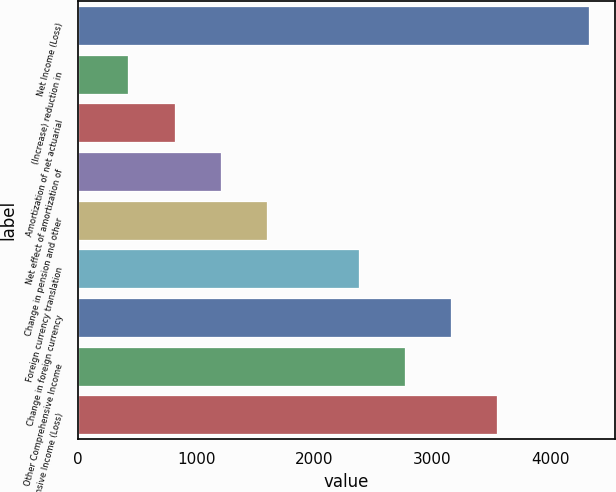<chart> <loc_0><loc_0><loc_500><loc_500><bar_chart><fcel>Net Income (Loss)<fcel>(Increase) reduction in<fcel>Amortization of net actuarial<fcel>Net effect of amortization of<fcel>Change in pension and other<fcel>Foreign currency translation<fcel>Change in foreign currency<fcel>Other Comprehensive Income<fcel>Comprehensive Income (Loss)<nl><fcel>4331.6<fcel>425.6<fcel>816.2<fcel>1206.8<fcel>1597.4<fcel>2378.6<fcel>3159.8<fcel>2769.2<fcel>3550.4<nl></chart> 